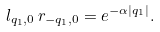Convert formula to latex. <formula><loc_0><loc_0><loc_500><loc_500>l _ { q _ { 1 } , 0 } \, r _ { - q _ { 1 } , 0 } = e ^ { - \alpha | q _ { 1 } | } .</formula> 